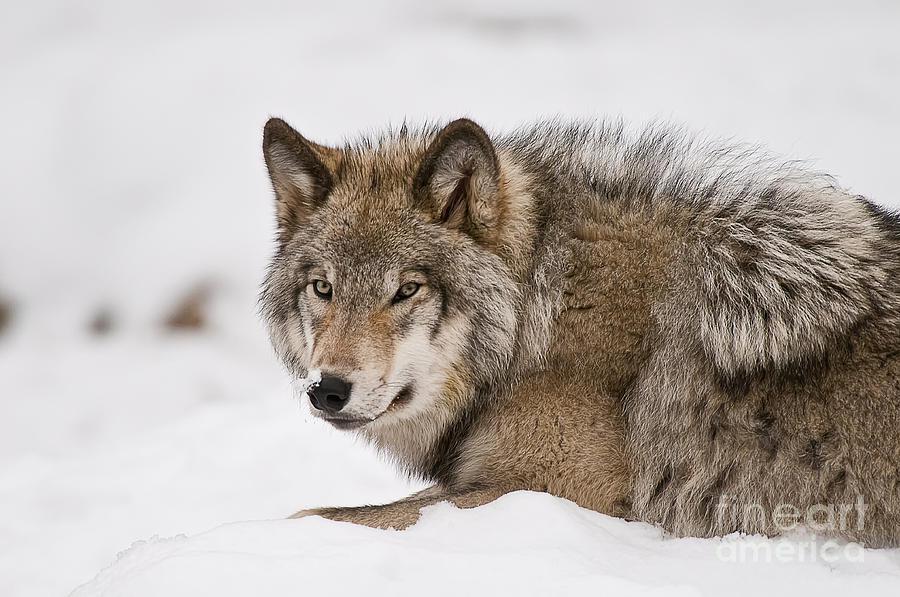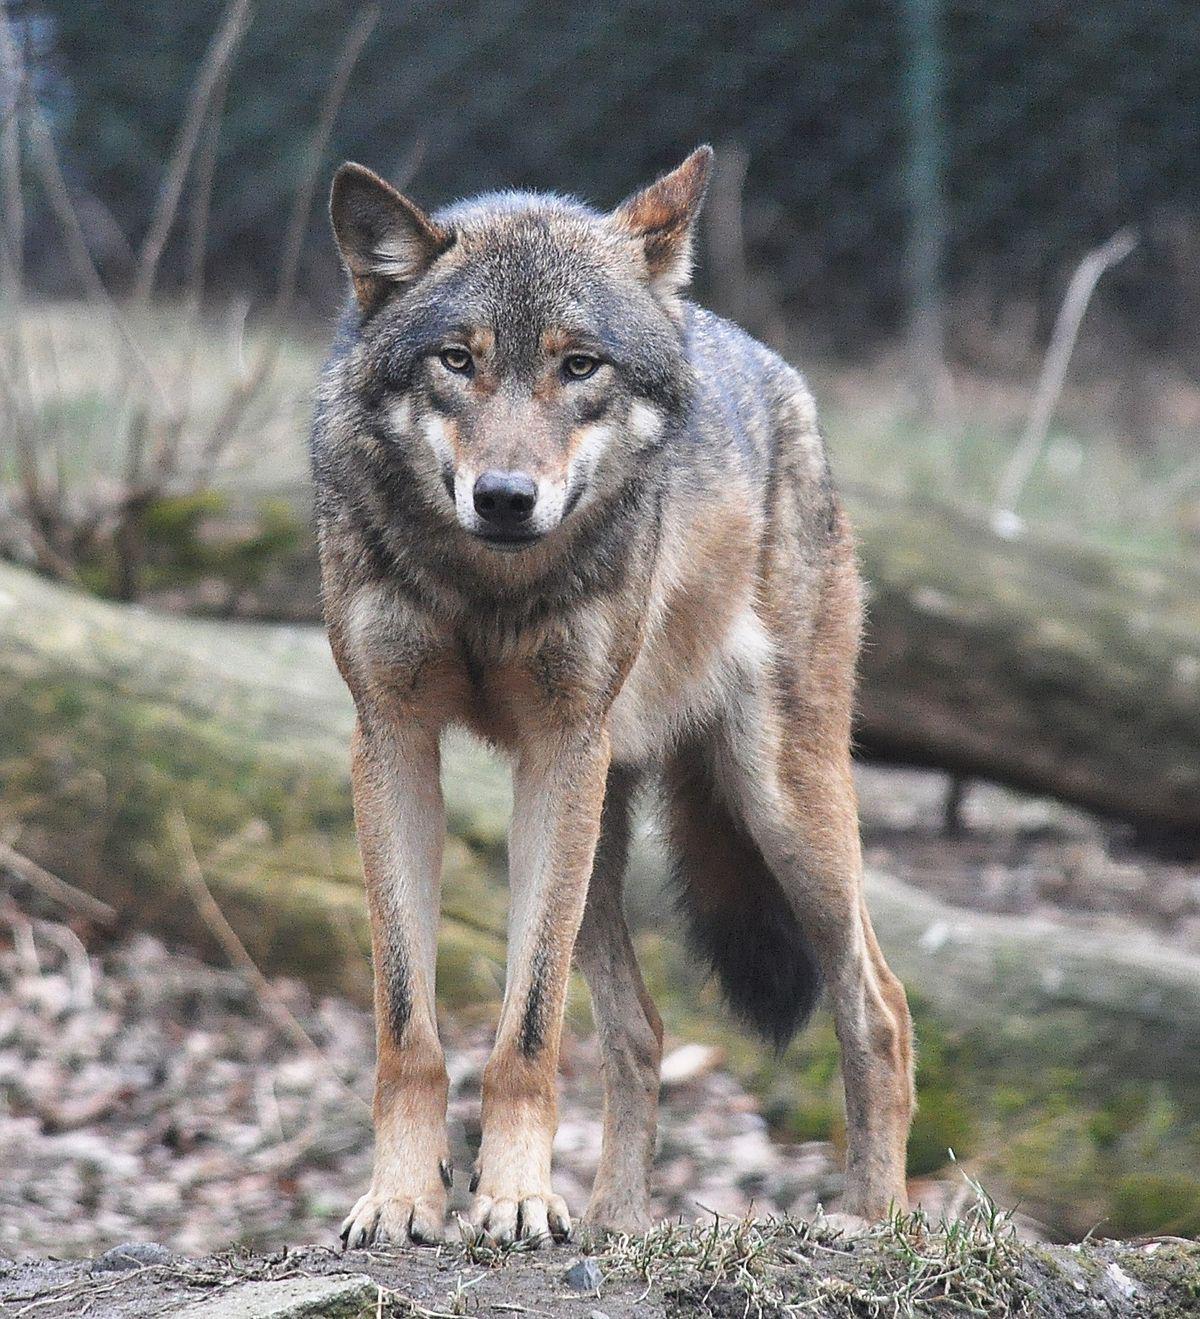The first image is the image on the left, the second image is the image on the right. Evaluate the accuracy of this statement regarding the images: "There is a wolf lying down with its head raised.". Is it true? Answer yes or no. Yes. 